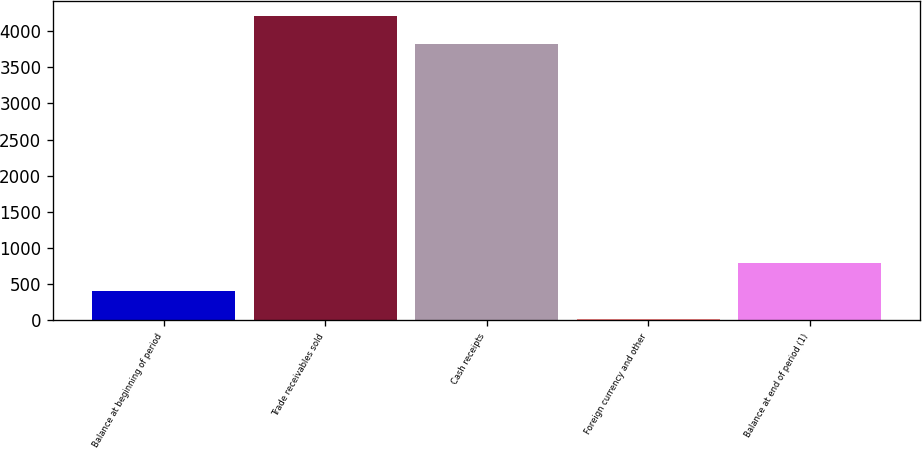<chart> <loc_0><loc_0><loc_500><loc_500><bar_chart><fcel>Balance at beginning of period<fcel>Trade receivables sold<fcel>Cash receipts<fcel>Foreign currency and other<fcel>Balance at end of period (1)<nl><fcel>407.3<fcel>4208.3<fcel>3815<fcel>14<fcel>800.6<nl></chart> 